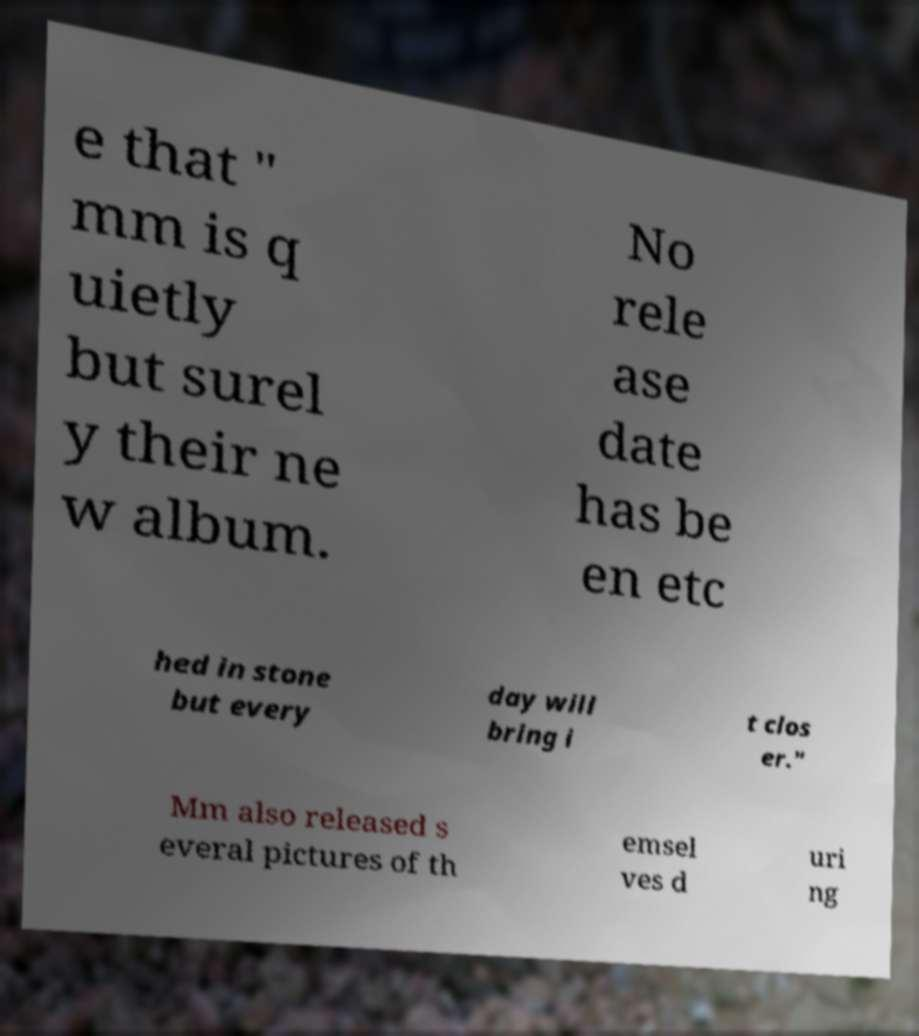Please identify and transcribe the text found in this image. e that " mm is q uietly but surel y their ne w album. No rele ase date has be en etc hed in stone but every day will bring i t clos er." Mm also released s everal pictures of th emsel ves d uri ng 